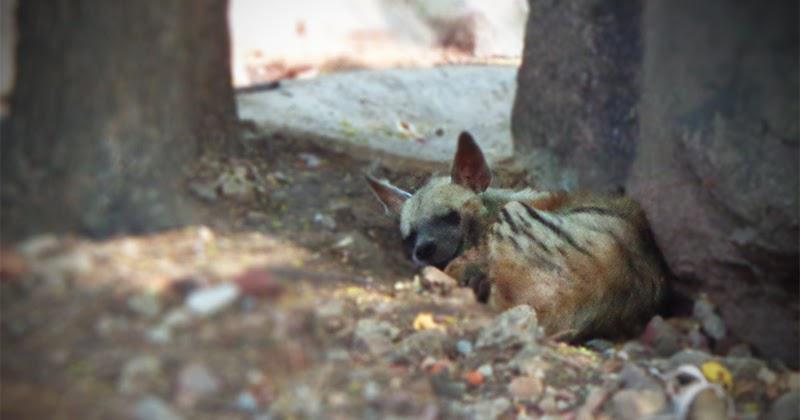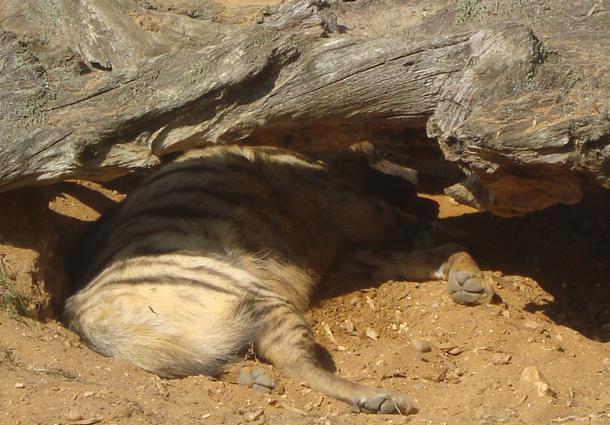The first image is the image on the left, the second image is the image on the right. For the images shown, is this caption "There are exactly two sleeping hyenas." true? Answer yes or no. Yes. The first image is the image on the left, the second image is the image on the right. Given the left and right images, does the statement "At least one animal is resting underneath of a rocky covering." hold true? Answer yes or no. Yes. 